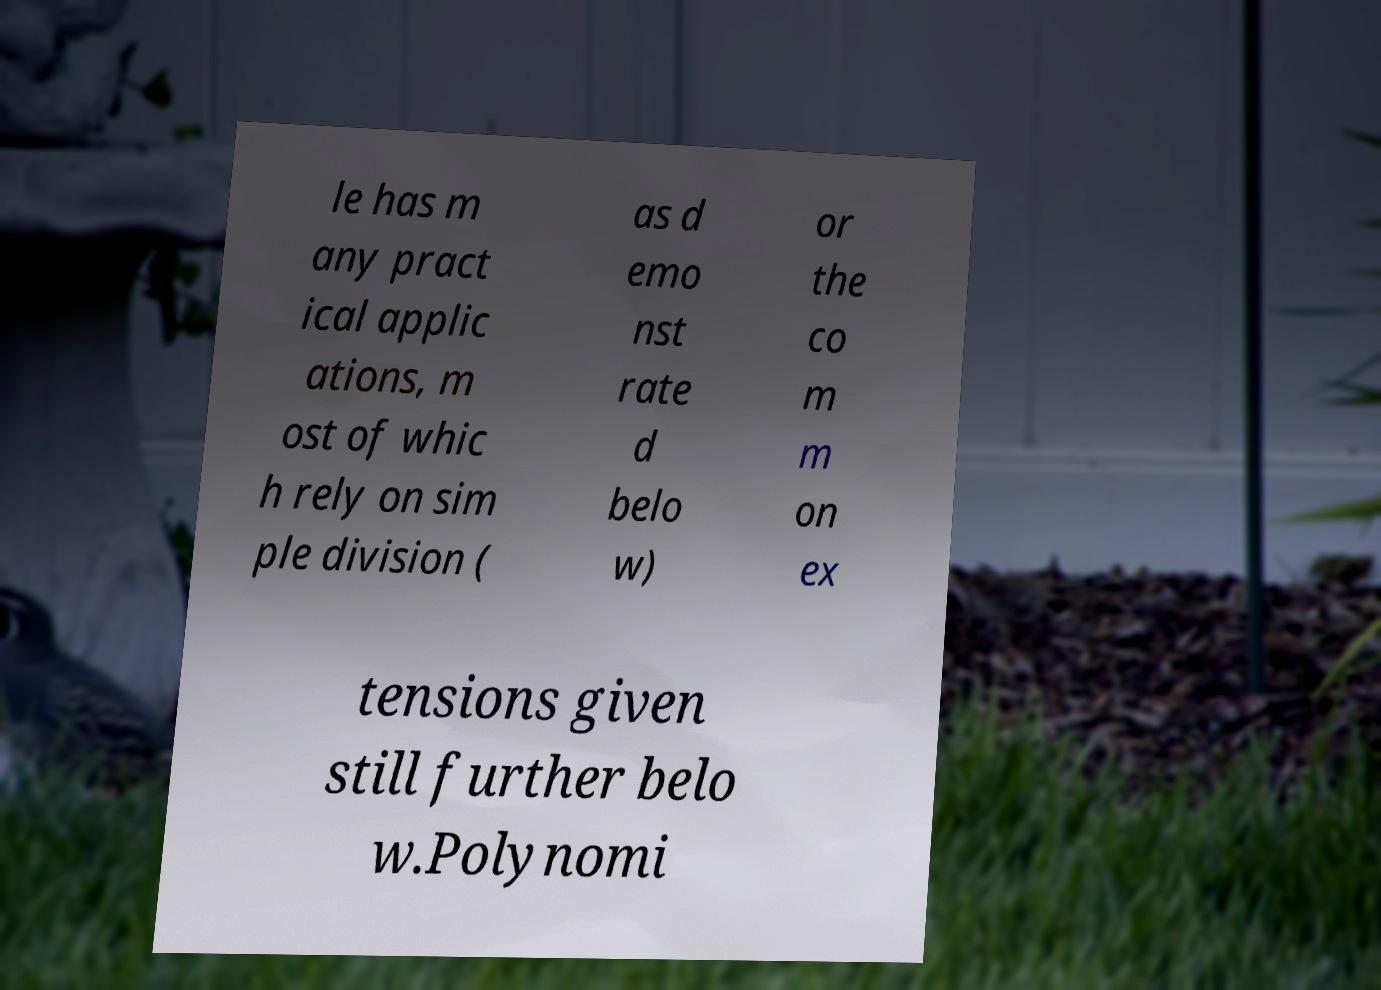Could you extract and type out the text from this image? le has m any pract ical applic ations, m ost of whic h rely on sim ple division ( as d emo nst rate d belo w) or the co m m on ex tensions given still further belo w.Polynomi 